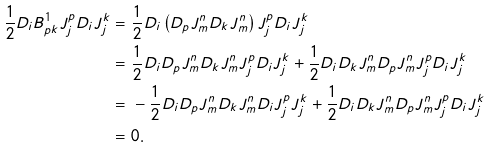<formula> <loc_0><loc_0><loc_500><loc_500>\frac { 1 } { 2 } D _ { i } B ^ { 1 } _ { p k } J _ { j } ^ { p } D _ { i } J _ { j } ^ { k } = & \ \frac { 1 } { 2 } D _ { i } \left ( D _ { p } J _ { m } ^ { n } D _ { k } J _ { m } ^ { n } \right ) J _ { j } ^ { p } D _ { i } J _ { j } ^ { k } \\ = & \ \frac { 1 } { 2 } D _ { i } D _ { p } J _ { m } ^ { n } D _ { k } J _ { m } ^ { n } J _ { j } ^ { p } D _ { i } J _ { j } ^ { k } + \frac { 1 } { 2 } D _ { i } D _ { k } J _ { m } ^ { n } D _ { p } J _ { m } ^ { n } J _ { j } ^ { p } D _ { i } J _ { j } ^ { k } \\ = & \ - \frac { 1 } { 2 } D _ { i } D _ { p } J _ { m } ^ { n } D _ { k } J _ { m } ^ { n } D _ { i } J _ { j } ^ { p } J _ { j } ^ { k } + \frac { 1 } { 2 } D _ { i } D _ { k } J _ { m } ^ { n } D _ { p } J _ { m } ^ { n } J _ { j } ^ { p } D _ { i } J _ { j } ^ { k } \\ = & \ 0 .</formula> 